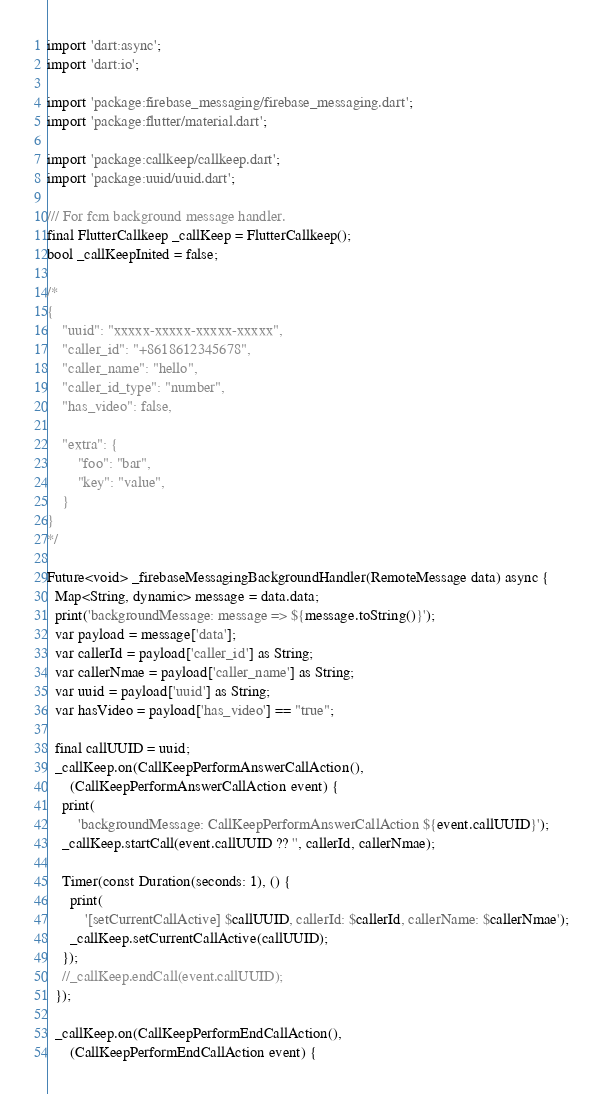Convert code to text. <code><loc_0><loc_0><loc_500><loc_500><_Dart_>import 'dart:async';
import 'dart:io';

import 'package:firebase_messaging/firebase_messaging.dart';
import 'package:flutter/material.dart';

import 'package:callkeep/callkeep.dart';
import 'package:uuid/uuid.dart';

/// For fcm background message handler.
final FlutterCallkeep _callKeep = FlutterCallkeep();
bool _callKeepInited = false;

/*
{
    "uuid": "xxxxx-xxxxx-xxxxx-xxxxx",
    "caller_id": "+8618612345678",
    "caller_name": "hello",
    "caller_id_type": "number", 
    "has_video": false,

    "extra": {
        "foo": "bar",
        "key": "value",
    }
}
*/

Future<void> _firebaseMessagingBackgroundHandler(RemoteMessage data) async {
  Map<String, dynamic> message = data.data;
  print('backgroundMessage: message => ${message.toString()}');
  var payload = message['data'];
  var callerId = payload['caller_id'] as String;
  var callerNmae = payload['caller_name'] as String;
  var uuid = payload['uuid'] as String;
  var hasVideo = payload['has_video'] == "true";

  final callUUID = uuid;
  _callKeep.on(CallKeepPerformAnswerCallAction(),
      (CallKeepPerformAnswerCallAction event) {
    print(
        'backgroundMessage: CallKeepPerformAnswerCallAction ${event.callUUID}');
    _callKeep.startCall(event.callUUID ?? '', callerId, callerNmae);

    Timer(const Duration(seconds: 1), () {
      print(
          '[setCurrentCallActive] $callUUID, callerId: $callerId, callerName: $callerNmae');
      _callKeep.setCurrentCallActive(callUUID);
    });
    //_callKeep.endCall(event.callUUID);
  });

  _callKeep.on(CallKeepPerformEndCallAction(),
      (CallKeepPerformEndCallAction event) {</code> 